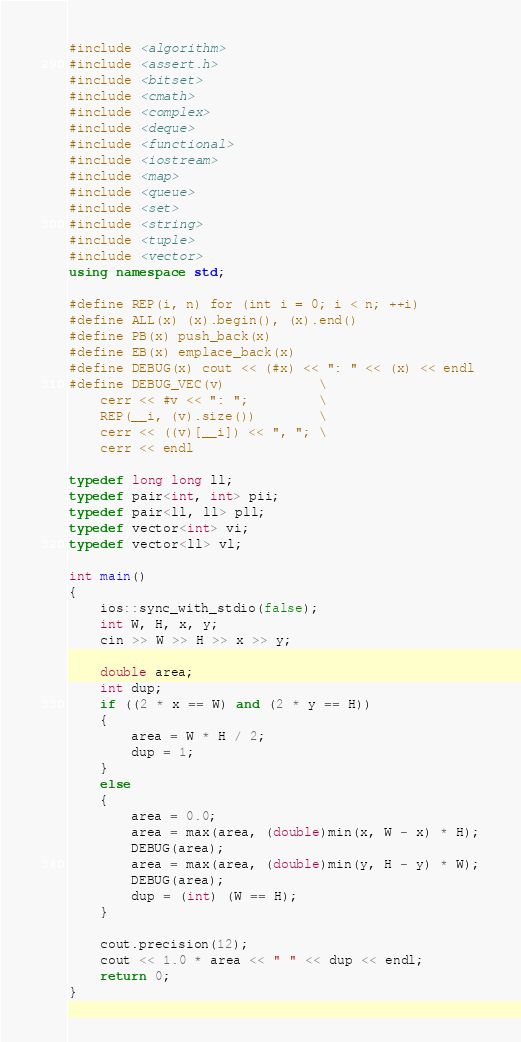<code> <loc_0><loc_0><loc_500><loc_500><_C++_>#include <algorithm>
#include <assert.h>
#include <bitset>
#include <cmath>
#include <complex>
#include <deque>
#include <functional>
#include <iostream>
#include <map>
#include <queue>
#include <set>
#include <string>
#include <tuple>
#include <vector>
using namespace std;

#define REP(i, n) for (int i = 0; i < n; ++i)
#define ALL(x) (x).begin(), (x).end()
#define PB(x) push_back(x)
#define EB(x) emplace_back(x)
#define DEBUG(x) cout << (#x) << ": " << (x) << endl
#define DEBUG_VEC(v)            \
    cerr << #v << ": ";         \
    REP(__i, (v).size())        \
    cerr << ((v)[__i]) << ", "; \
    cerr << endl

typedef long long ll;
typedef pair<int, int> pii;
typedef pair<ll, ll> pll;
typedef vector<int> vi;
typedef vector<ll> vl;

int main()
{
    ios::sync_with_stdio(false);
    int W, H, x, y;
    cin >> W >> H >> x >> y;

    double area;
    int dup;
    if ((2 * x == W) and (2 * y == H))
    {
        area = W * H / 2;
        dup = 1;
    }
    else 
    {
        area = 0.0;
        area = max(area, (double)min(x, W - x) * H);
        DEBUG(area);
        area = max(area, (double)min(y, H - y) * W);
        DEBUG(area);
        dup = (int) (W == H);
    }

    cout.precision(12);
    cout << 1.0 * area << " " << dup << endl;
    return 0;
}
</code> 